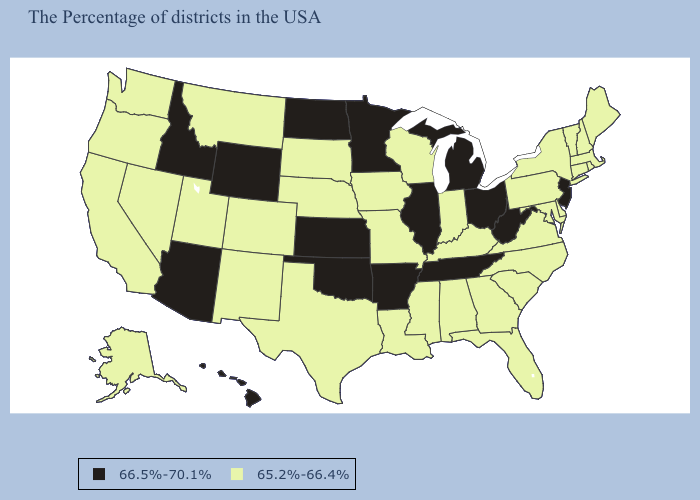What is the lowest value in states that border Pennsylvania?
Concise answer only. 65.2%-66.4%. What is the value of Delaware?
Concise answer only. 65.2%-66.4%. Name the states that have a value in the range 66.5%-70.1%?
Concise answer only. New Jersey, West Virginia, Ohio, Michigan, Tennessee, Illinois, Arkansas, Minnesota, Kansas, Oklahoma, North Dakota, Wyoming, Arizona, Idaho, Hawaii. What is the lowest value in the USA?
Keep it brief. 65.2%-66.4%. What is the value of Utah?
Short answer required. 65.2%-66.4%. What is the lowest value in states that border Louisiana?
Quick response, please. 65.2%-66.4%. What is the highest value in states that border Colorado?
Answer briefly. 66.5%-70.1%. Does Vermont have the same value as Oregon?
Answer briefly. Yes. Which states have the highest value in the USA?
Give a very brief answer. New Jersey, West Virginia, Ohio, Michigan, Tennessee, Illinois, Arkansas, Minnesota, Kansas, Oklahoma, North Dakota, Wyoming, Arizona, Idaho, Hawaii. Does the map have missing data?
Be succinct. No. Name the states that have a value in the range 66.5%-70.1%?
Answer briefly. New Jersey, West Virginia, Ohio, Michigan, Tennessee, Illinois, Arkansas, Minnesota, Kansas, Oklahoma, North Dakota, Wyoming, Arizona, Idaho, Hawaii. What is the value of Idaho?
Be succinct. 66.5%-70.1%. How many symbols are there in the legend?
Answer briefly. 2. Name the states that have a value in the range 65.2%-66.4%?
Answer briefly. Maine, Massachusetts, Rhode Island, New Hampshire, Vermont, Connecticut, New York, Delaware, Maryland, Pennsylvania, Virginia, North Carolina, South Carolina, Florida, Georgia, Kentucky, Indiana, Alabama, Wisconsin, Mississippi, Louisiana, Missouri, Iowa, Nebraska, Texas, South Dakota, Colorado, New Mexico, Utah, Montana, Nevada, California, Washington, Oregon, Alaska. 